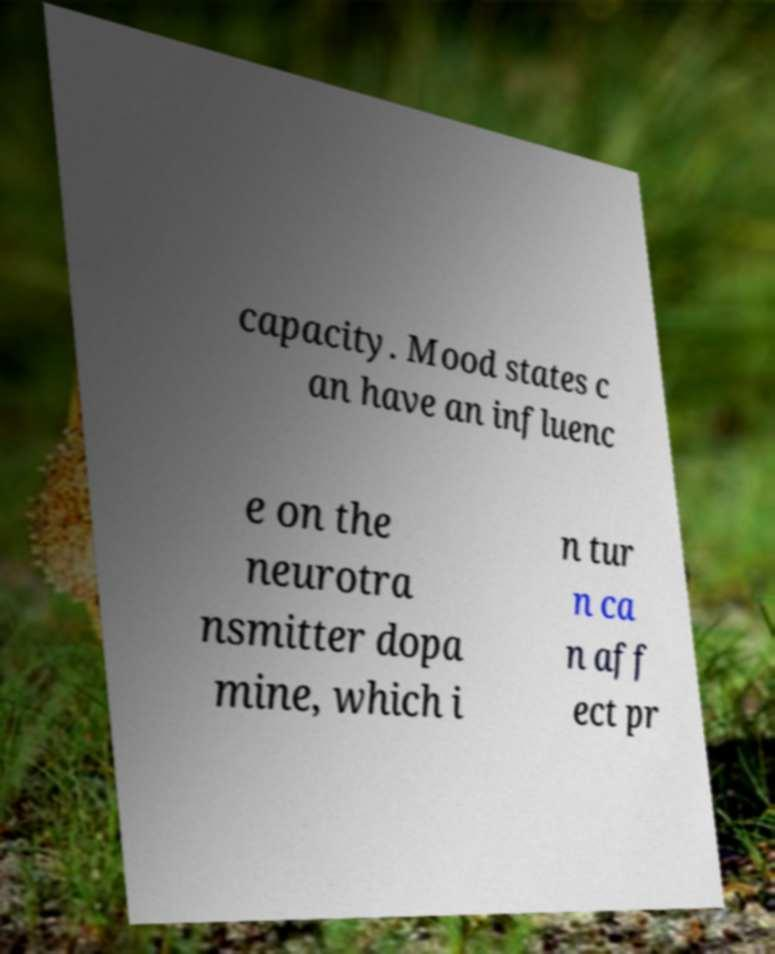For documentation purposes, I need the text within this image transcribed. Could you provide that? capacity. Mood states c an have an influenc e on the neurotra nsmitter dopa mine, which i n tur n ca n aff ect pr 